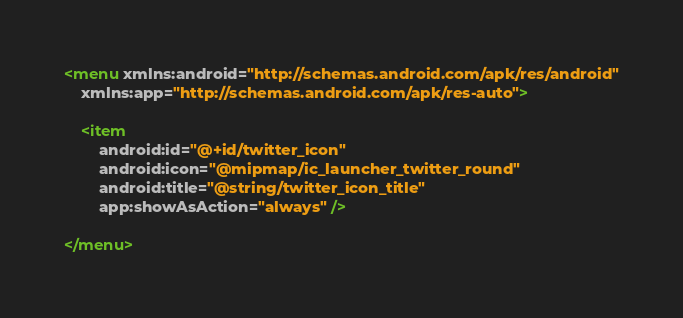<code> <loc_0><loc_0><loc_500><loc_500><_XML_><menu xmlns:android="http://schemas.android.com/apk/res/android"
    xmlns:app="http://schemas.android.com/apk/res-auto">

    <item
        android:id="@+id/twitter_icon"
        android:icon="@mipmap/ic_launcher_twitter_round"
        android:title="@string/twitter_icon_title"
        app:showAsAction="always" />

</menu>
</code> 